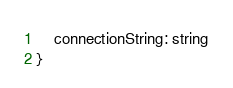Convert code to text. <code><loc_0><loc_0><loc_500><loc_500><_TypeScript_>    connectionString: string
}</code> 